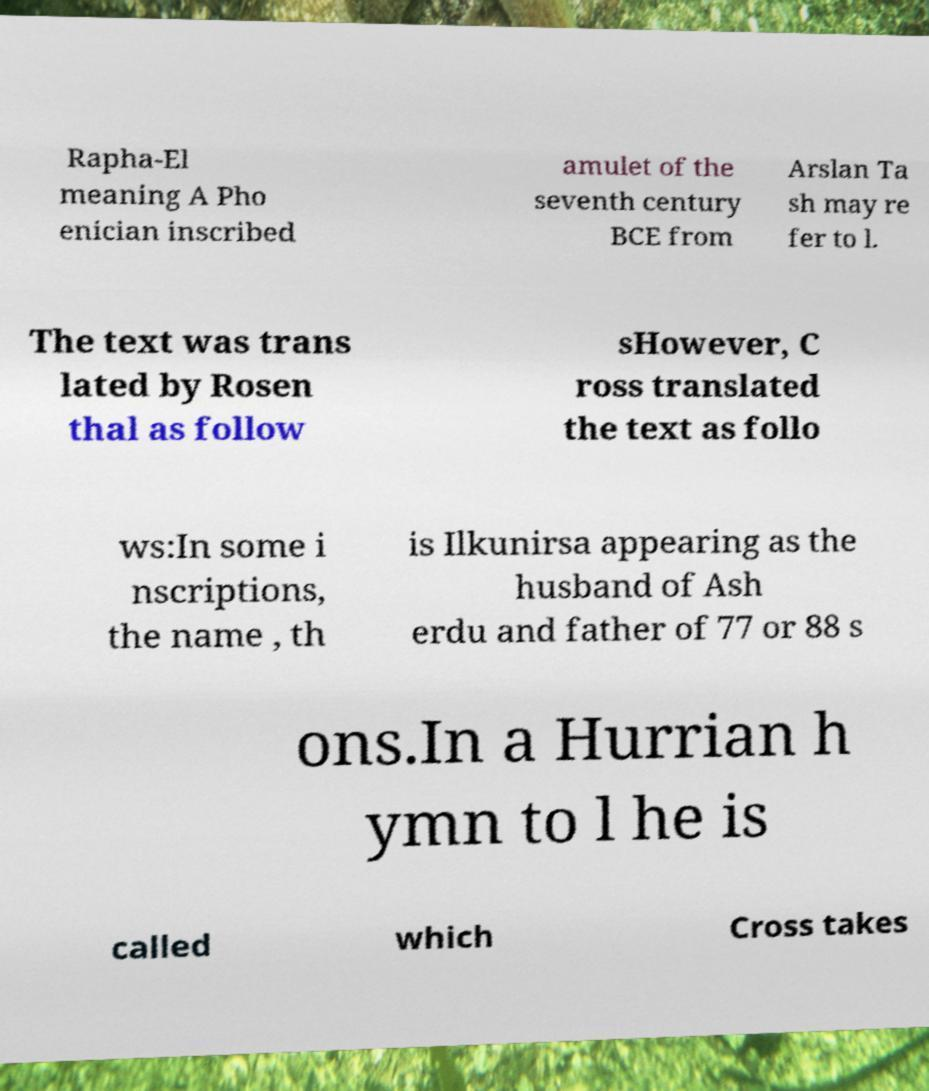Could you assist in decoding the text presented in this image and type it out clearly? Rapha-El meaning A Pho enician inscribed amulet of the seventh century BCE from Arslan Ta sh may re fer to l. The text was trans lated by Rosen thal as follow sHowever, C ross translated the text as follo ws:In some i nscriptions, the name , th is Ilkunirsa appearing as the husband of Ash erdu and father of 77 or 88 s ons.In a Hurrian h ymn to l he is called which Cross takes 